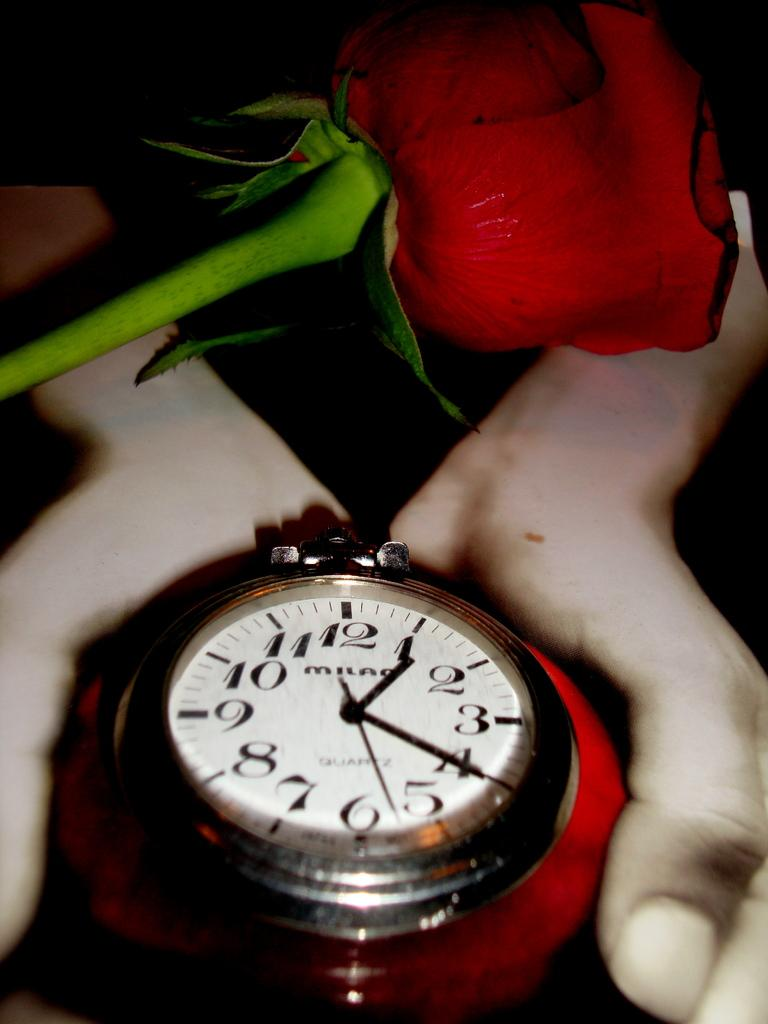<image>
Give a short and clear explanation of the subsequent image. A red rose hovers over a large Milan watch. 